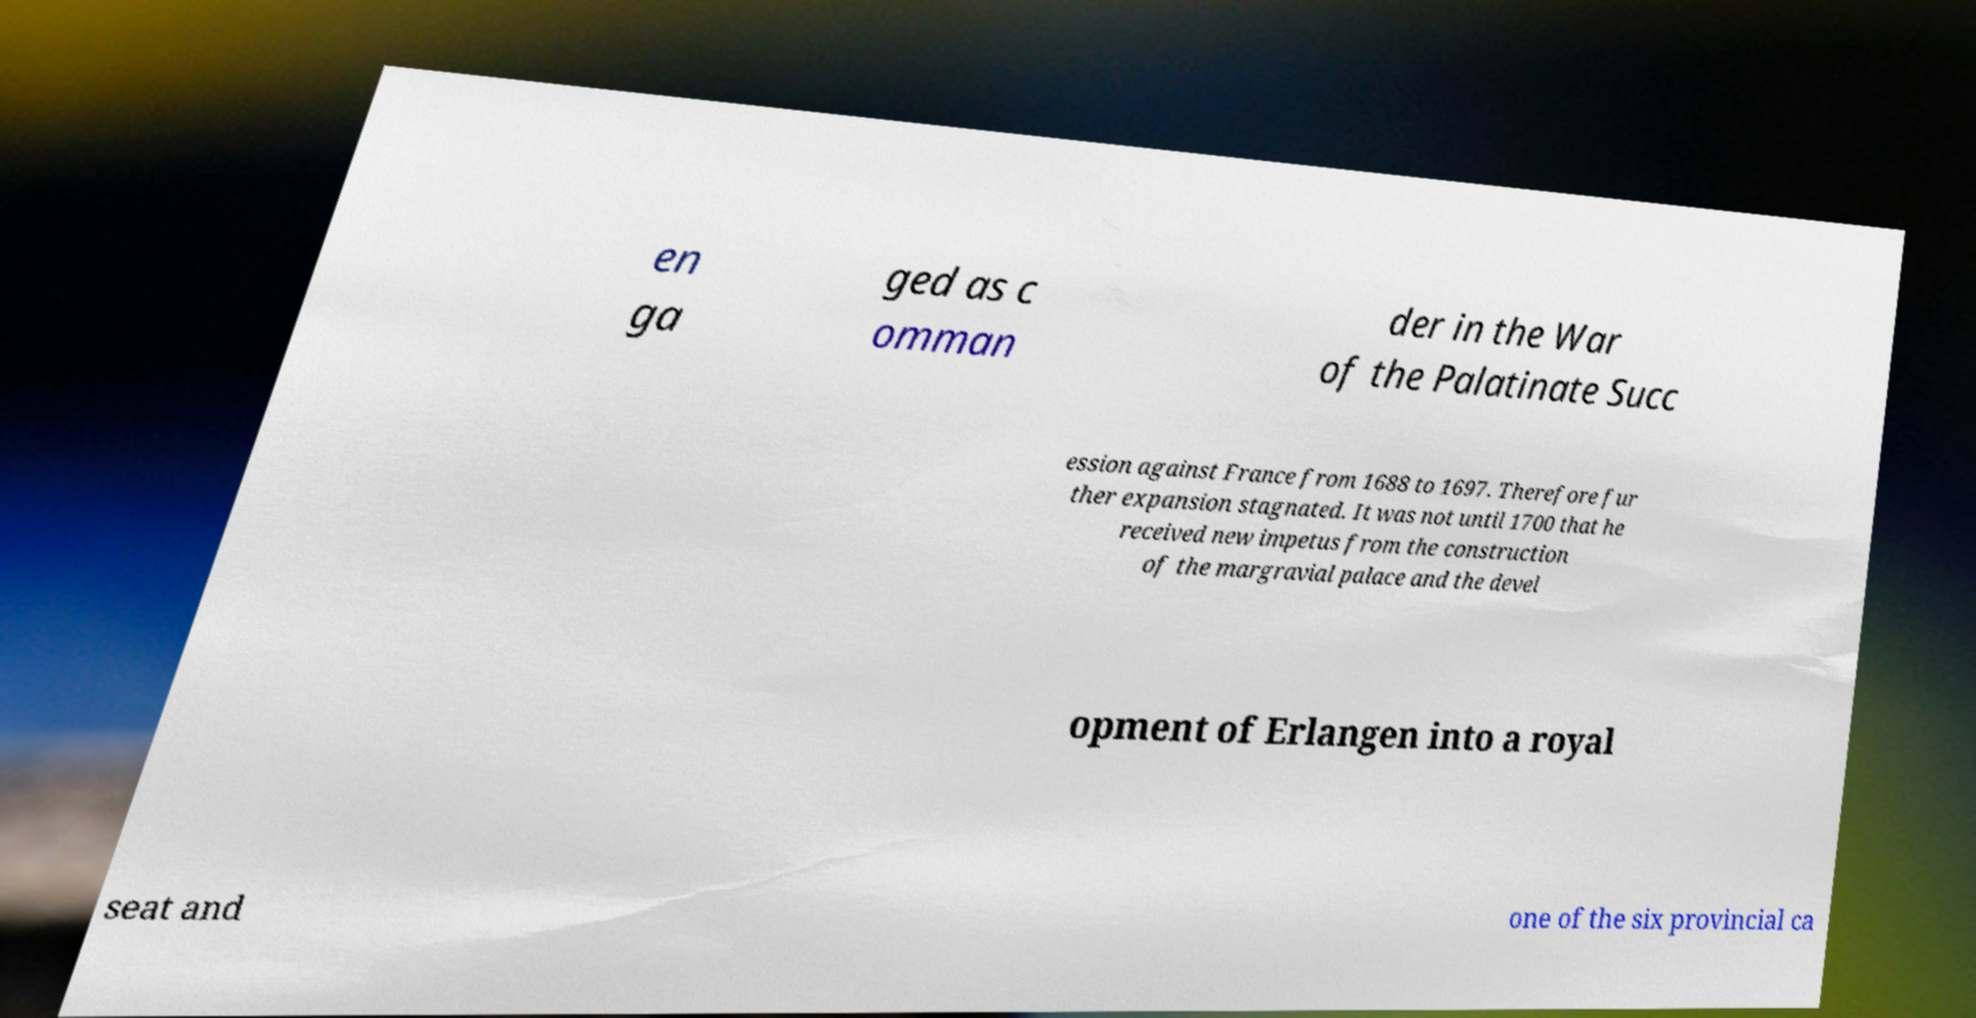Could you extract and type out the text from this image? en ga ged as c omman der in the War of the Palatinate Succ ession against France from 1688 to 1697. Therefore fur ther expansion stagnated. It was not until 1700 that he received new impetus from the construction of the margravial palace and the devel opment of Erlangen into a royal seat and one of the six provincial ca 